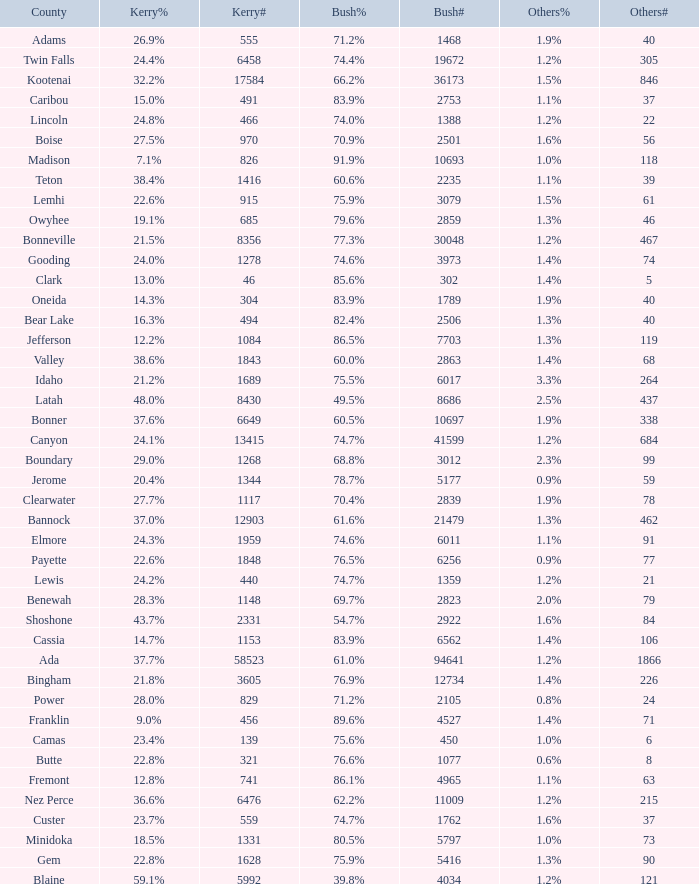Write the full table. {'header': ['County', 'Kerry%', 'Kerry#', 'Bush%', 'Bush#', 'Others%', 'Others#'], 'rows': [['Adams', '26.9%', '555', '71.2%', '1468', '1.9%', '40'], ['Twin Falls', '24.4%', '6458', '74.4%', '19672', '1.2%', '305'], ['Kootenai', '32.2%', '17584', '66.2%', '36173', '1.5%', '846'], ['Caribou', '15.0%', '491', '83.9%', '2753', '1.1%', '37'], ['Lincoln', '24.8%', '466', '74.0%', '1388', '1.2%', '22'], ['Boise', '27.5%', '970', '70.9%', '2501', '1.6%', '56'], ['Madison', '7.1%', '826', '91.9%', '10693', '1.0%', '118'], ['Teton', '38.4%', '1416', '60.6%', '2235', '1.1%', '39'], ['Lemhi', '22.6%', '915', '75.9%', '3079', '1.5%', '61'], ['Owyhee', '19.1%', '685', '79.6%', '2859', '1.3%', '46'], ['Bonneville', '21.5%', '8356', '77.3%', '30048', '1.2%', '467'], ['Gooding', '24.0%', '1278', '74.6%', '3973', '1.4%', '74'], ['Clark', '13.0%', '46', '85.6%', '302', '1.4%', '5'], ['Oneida', '14.3%', '304', '83.9%', '1789', '1.9%', '40'], ['Bear Lake', '16.3%', '494', '82.4%', '2506', '1.3%', '40'], ['Jefferson', '12.2%', '1084', '86.5%', '7703', '1.3%', '119'], ['Valley', '38.6%', '1843', '60.0%', '2863', '1.4%', '68'], ['Idaho', '21.2%', '1689', '75.5%', '6017', '3.3%', '264'], ['Latah', '48.0%', '8430', '49.5%', '8686', '2.5%', '437'], ['Bonner', '37.6%', '6649', '60.5%', '10697', '1.9%', '338'], ['Canyon', '24.1%', '13415', '74.7%', '41599', '1.2%', '684'], ['Boundary', '29.0%', '1268', '68.8%', '3012', '2.3%', '99'], ['Jerome', '20.4%', '1344', '78.7%', '5177', '0.9%', '59'], ['Clearwater', '27.7%', '1117', '70.4%', '2839', '1.9%', '78'], ['Bannock', '37.0%', '12903', '61.6%', '21479', '1.3%', '462'], ['Elmore', '24.3%', '1959', '74.6%', '6011', '1.1%', '91'], ['Payette', '22.6%', '1848', '76.5%', '6256', '0.9%', '77'], ['Lewis', '24.2%', '440', '74.7%', '1359', '1.2%', '21'], ['Benewah', '28.3%', '1148', '69.7%', '2823', '2.0%', '79'], ['Shoshone', '43.7%', '2331', '54.7%', '2922', '1.6%', '84'], ['Cassia', '14.7%', '1153', '83.9%', '6562', '1.4%', '106'], ['Ada', '37.7%', '58523', '61.0%', '94641', '1.2%', '1866'], ['Bingham', '21.8%', '3605', '76.9%', '12734', '1.4%', '226'], ['Power', '28.0%', '829', '71.2%', '2105', '0.8%', '24'], ['Franklin', '9.0%', '456', '89.6%', '4527', '1.4%', '71'], ['Camas', '23.4%', '139', '75.6%', '450', '1.0%', '6'], ['Butte', '22.8%', '321', '76.6%', '1077', '0.6%', '8'], ['Fremont', '12.8%', '741', '86.1%', '4965', '1.1%', '63'], ['Nez Perce', '36.6%', '6476', '62.2%', '11009', '1.2%', '215'], ['Custer', '23.7%', '559', '74.7%', '1762', '1.6%', '37'], ['Minidoka', '18.5%', '1331', '80.5%', '5797', '1.0%', '73'], ['Gem', '22.8%', '1628', '75.9%', '5416', '1.3%', '90'], ['Blaine', '59.1%', '5992', '39.8%', '4034', '1.2%', '121']]} What percentage of the votes in Oneida did Kerry win? 14.3%. 